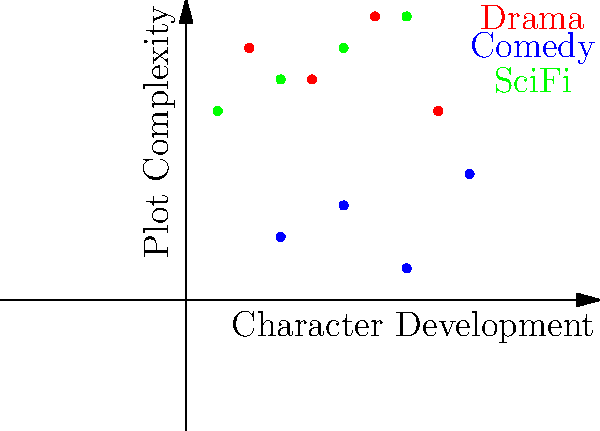As a successful TV series creator, you're analyzing different genres based on character development and plot complexity. The scatter plot shows data points for Drama (red), Comedy (blue), and Sci-Fi (green) TV shows. Which genre typically exhibits the highest average plot complexity while maintaining moderate to high character development? To answer this question, we need to analyze the scatter plot and interpret the data points for each genre:

1. Drama (red):
   - Character Development: Ranges from low to high (0.2 to 0.8)
   - Plot Complexity: Generally high (0.6 to 0.9)

2. Comedy (blue):
   - Character Development: Ranges from low to high (0.3 to 0.9)
   - Plot Complexity: Generally low (0.1 to 0.4)

3. Sci-Fi (green):
   - Character Development: Ranges from low to moderately high (0.1 to 0.7)
   - Plot Complexity: Consistently high (0.6 to 0.9)

Comparing the three genres:
- Drama shows a balance between character development and plot complexity.
- Comedy shows high variability in character development but consistently low plot complexity.
- Sci-Fi shows a trend of increasing plot complexity as character development increases.

Sci-Fi exhibits the highest average plot complexity (most points are above 0.7 on the y-axis) while maintaining moderate to high character development (points spread from 0.1 to 0.7 on the x-axis).
Answer: Sci-Fi 